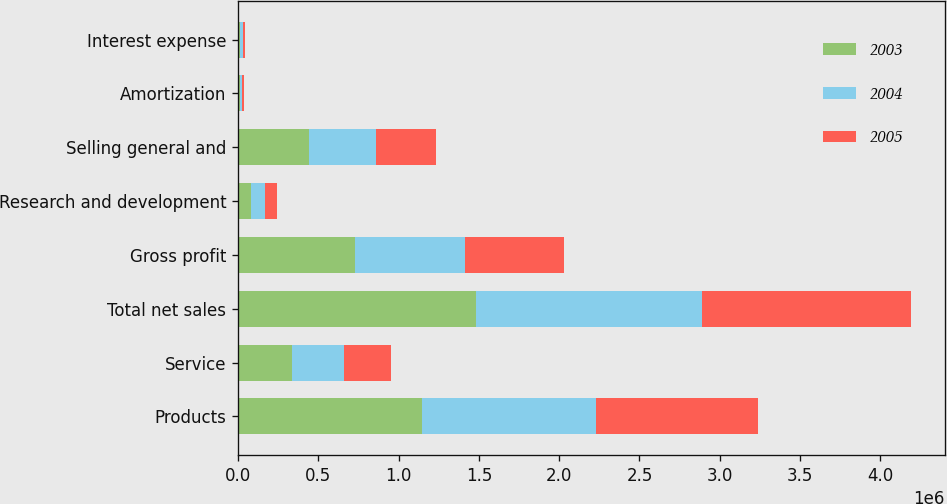<chart> <loc_0><loc_0><loc_500><loc_500><stacked_bar_chart><ecel><fcel>Products<fcel>Service<fcel>Total net sales<fcel>Gross profit<fcel>Research and development<fcel>Selling general and<fcel>Amortization<fcel>Interest expense<nl><fcel>2003<fcel>1.14431e+06<fcel>338163<fcel>1.48247e+06<fcel>730319<fcel>81893<fcel>441702<fcel>11436<fcel>14880<nl><fcel>2004<fcel>1.0821e+06<fcel>322357<fcel>1.40445e+06<fcel>682407<fcel>83217<fcel>419780<fcel>12256<fcel>12888<nl><fcel>2005<fcel>1.01472e+06<fcel>289709<fcel>1.30443e+06<fcel>618176<fcel>78003<fcel>372822<fcel>11724<fcel>14153<nl></chart> 